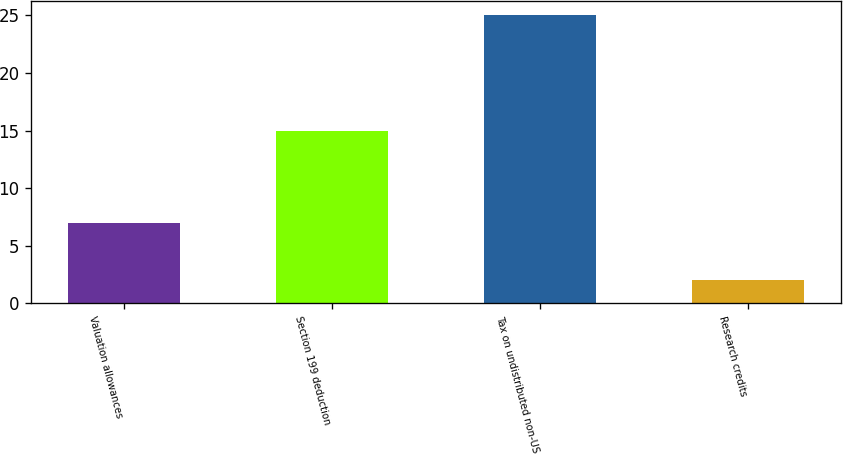Convert chart to OTSL. <chart><loc_0><loc_0><loc_500><loc_500><bar_chart><fcel>Valuation allowances<fcel>Section 199 deduction<fcel>Tax on undistributed non-US<fcel>Research credits<nl><fcel>7<fcel>15<fcel>25<fcel>2<nl></chart> 